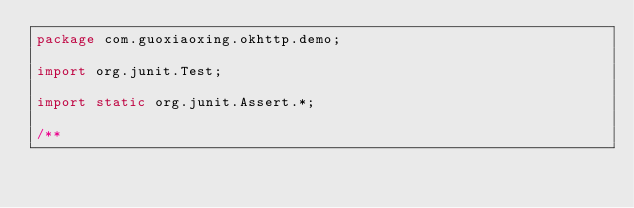Convert code to text. <code><loc_0><loc_0><loc_500><loc_500><_Java_>package com.guoxiaoxing.okhttp.demo;

import org.junit.Test;

import static org.junit.Assert.*;

/**</code> 